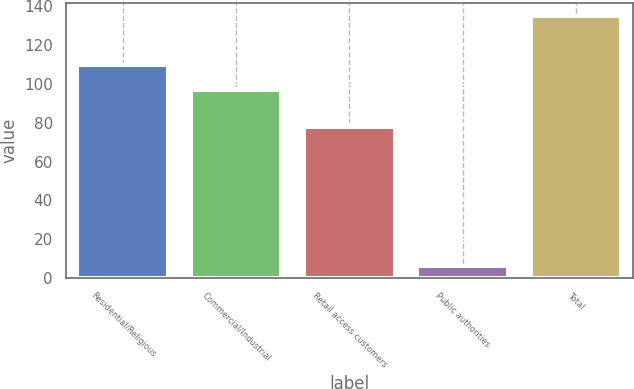Convert chart. <chart><loc_0><loc_0><loc_500><loc_500><bar_chart><fcel>Residential/Religious<fcel>Commercial/Industrial<fcel>Retail access customers<fcel>Public authorities<fcel>Total<nl><fcel>110<fcel>97<fcel>78<fcel>6<fcel>135<nl></chart> 